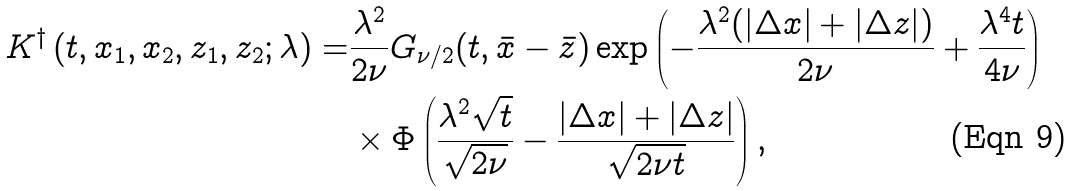Convert formula to latex. <formula><loc_0><loc_0><loc_500><loc_500>K ^ { \dagger } \left ( t , x _ { 1 } , x _ { 2 } , z _ { 1 } , z _ { 2 } ; \lambda \right ) = & \frac { \lambda ^ { 2 } } { 2 \nu } G _ { \nu / 2 } ( t , \bar { x } - \bar { z } ) \exp \left ( - \frac { \lambda ^ { 2 } ( | \Delta x | + | \Delta z | ) } { 2 \nu } + \frac { \lambda ^ { 4 } t } { 4 \nu } \right ) \\ & \times \Phi \left ( \frac { \lambda ^ { 2 } \sqrt { t } } { \sqrt { 2 \nu } } - \frac { | \Delta x | + | \Delta z | } { \sqrt { 2 \nu t } } \right ) ,</formula> 